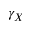Convert formula to latex. <formula><loc_0><loc_0><loc_500><loc_500>\gamma _ { X }</formula> 